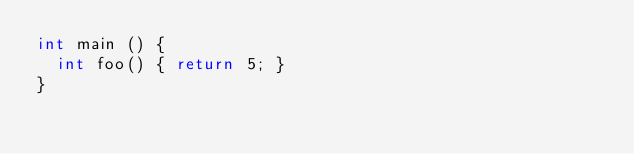<code> <loc_0><loc_0><loc_500><loc_500><_C_>int main () {
	int foo() { return 5; }
}
</code> 